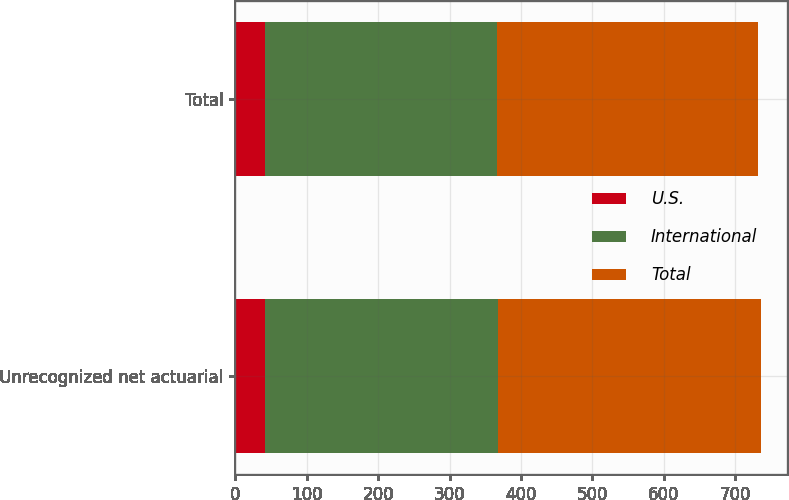Convert chart. <chart><loc_0><loc_0><loc_500><loc_500><stacked_bar_chart><ecel><fcel>Unrecognized net actuarial<fcel>Total<nl><fcel>U.S.<fcel>42<fcel>42<nl><fcel>International<fcel>325.9<fcel>323.8<nl><fcel>Total<fcel>367.9<fcel>365.8<nl></chart> 